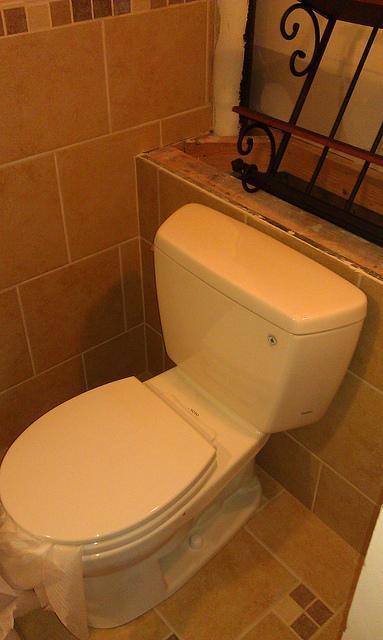How many toothbrushes are in this photo?
Give a very brief answer. 0. 